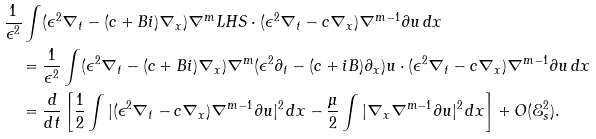Convert formula to latex. <formula><loc_0><loc_0><loc_500><loc_500>& \frac { 1 } { \epsilon ^ { 2 } } \int ( \epsilon ^ { 2 } \nabla _ { t } - ( c + B i ) \nabla _ { x } ) \nabla ^ { m } L H S \cdot ( \epsilon ^ { 2 } \nabla _ { t } - c \nabla _ { x } ) \nabla ^ { m - 1 } \partial u \, d x \\ & \quad = \frac { 1 } { \epsilon ^ { 2 } } \int ( \epsilon ^ { 2 } \nabla _ { t } - ( c + B i ) \nabla _ { x } ) \nabla ^ { m } ( \epsilon ^ { 2 } \partial _ { t } - ( c + i B ) \partial _ { x } ) u \cdot ( \epsilon ^ { 2 } \nabla _ { t } - c \nabla _ { x } ) \nabla ^ { m - 1 } \partial u \, d x \\ & \quad = \frac { d } { d t } \left [ \frac { 1 } { 2 } \int | ( \epsilon ^ { 2 } \nabla _ { t } - c \nabla _ { x } ) \nabla ^ { m - 1 } \partial u | ^ { 2 } \, d x - \frac { \mu } { 2 } \int | \nabla _ { x } \nabla ^ { m - 1 } \partial u | ^ { 2 } \, d x \right ] + O ( \mathcal { E } _ { s } ^ { 2 } ) .</formula> 